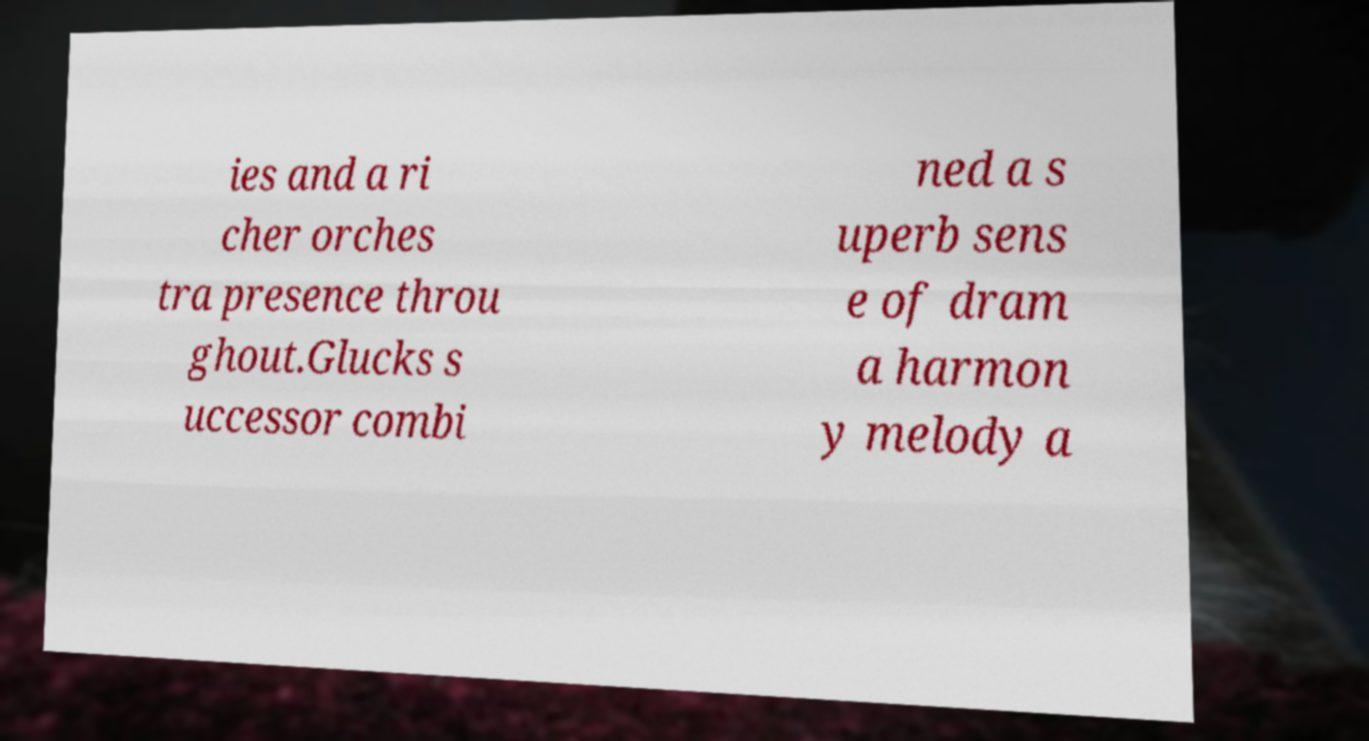For documentation purposes, I need the text within this image transcribed. Could you provide that? ies and a ri cher orches tra presence throu ghout.Glucks s uccessor combi ned a s uperb sens e of dram a harmon y melody a 